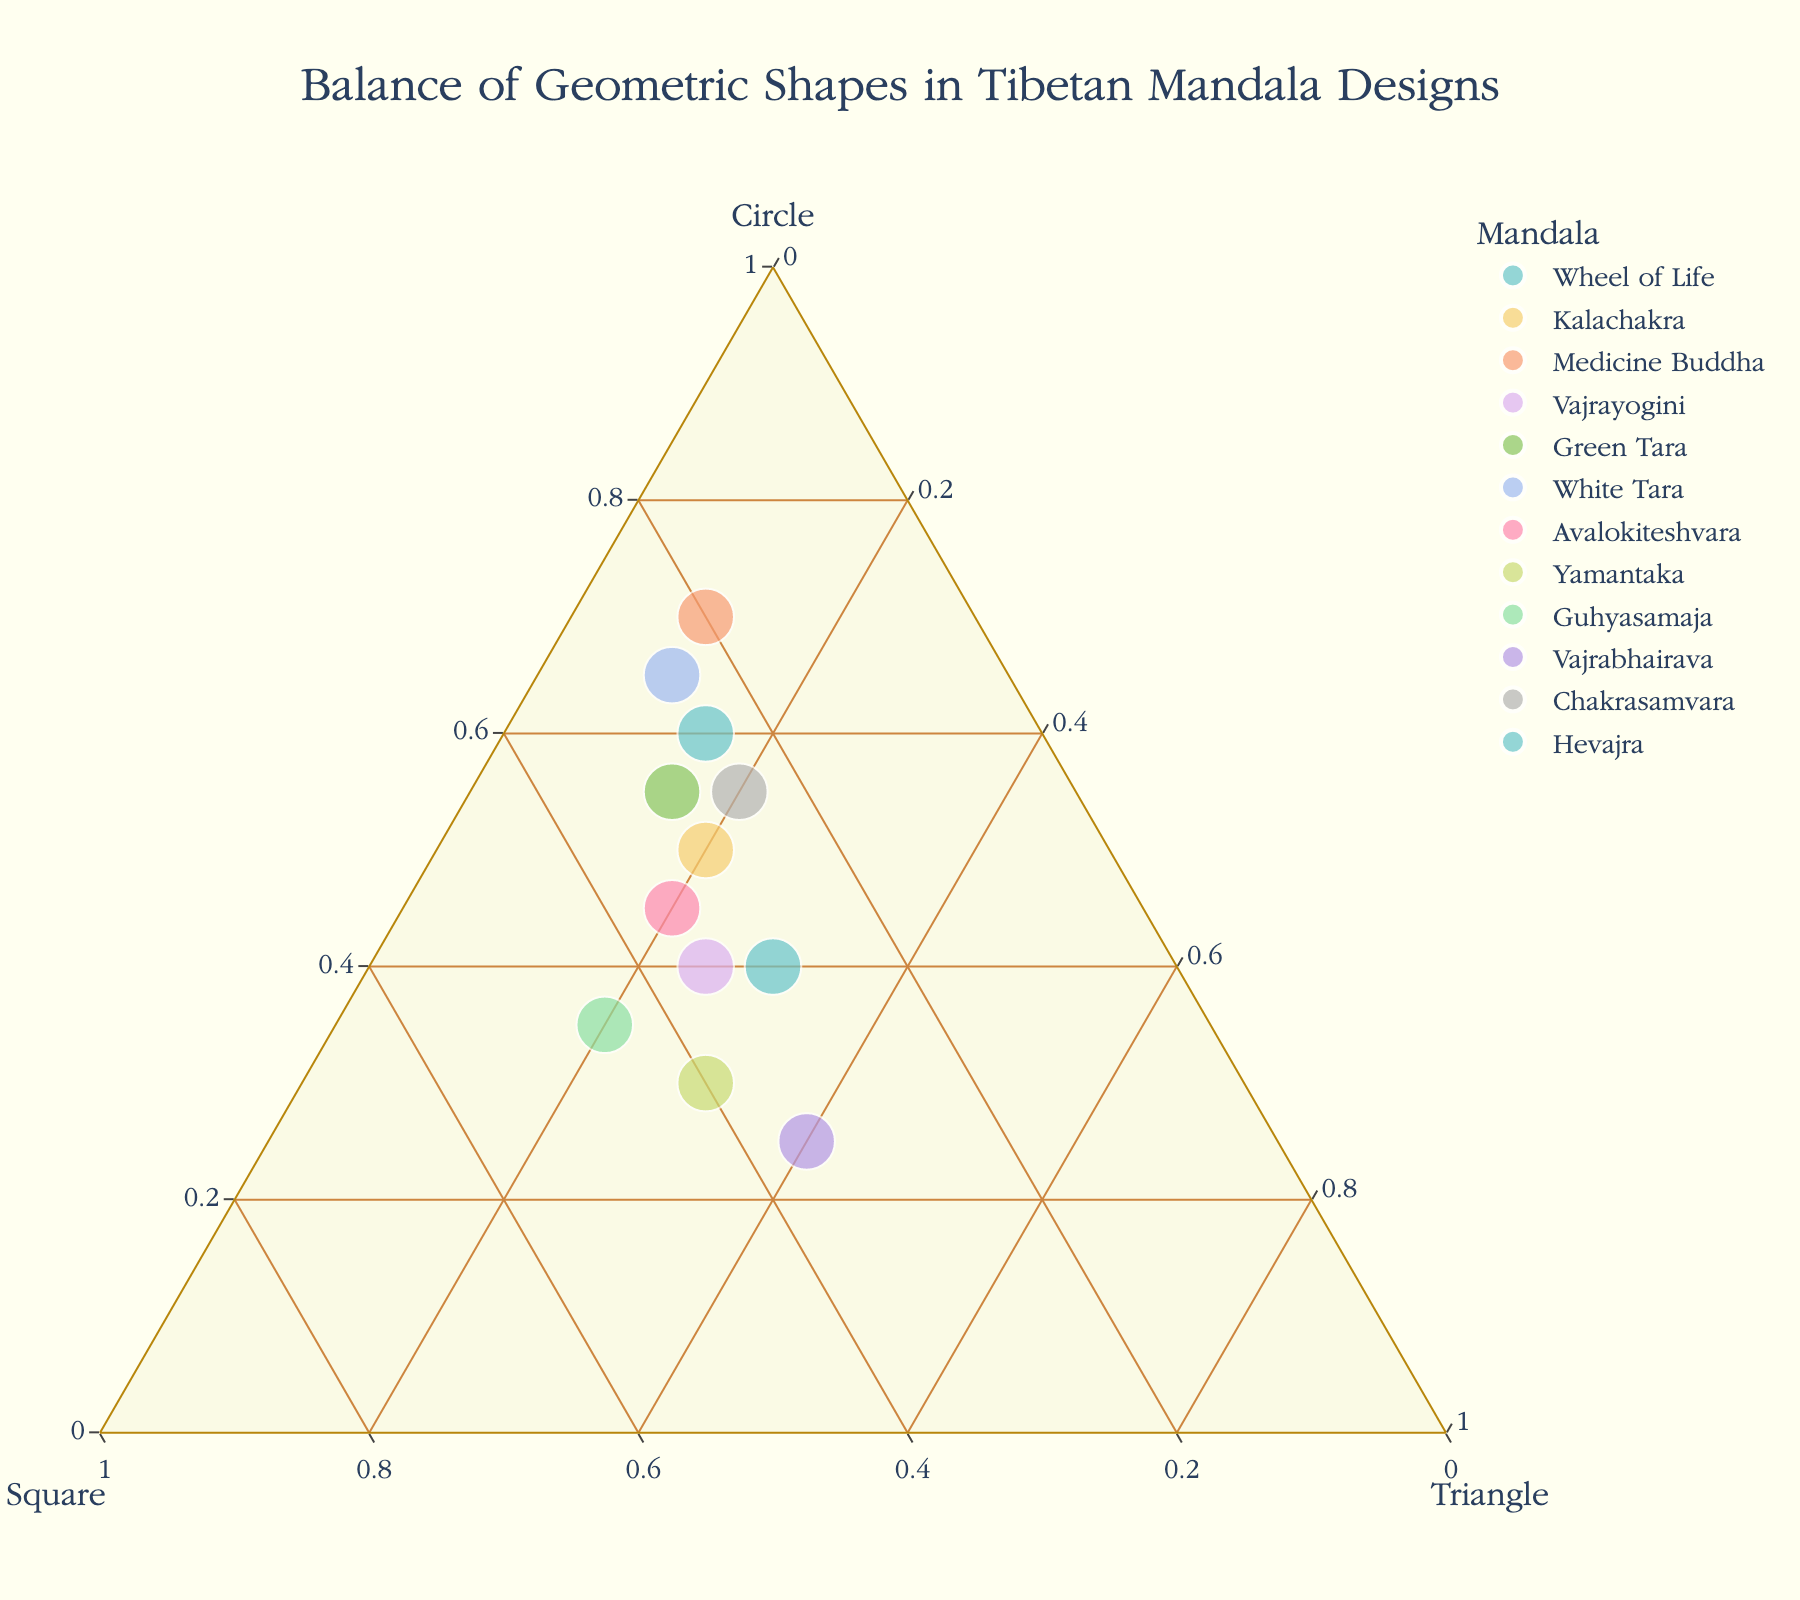what is the title of the plot? The title is displayed at the top of the plot and describes what the plot is about.
Answer: Balance of Geometric Shapes in Tibetan Mandala Designs How many data points are represented in the plot? The plot visualizes each mandala as an individual data point. Counting the number of distinct points will give the total number of data points.
Answer: 12 Which mandala has the highest proportion of triangles? Look for the point closest to the triangle vertex of the ternary plot, representing the highest proportion of triangles.
Answer: Vajrabhairava Which mandala is located exactly in the middle of the plot, and what does it indicate? The middle of the ternary plot would equally balance the three shapes. Identify the point closest to the center of the plot.
Answer: None Which mandala has an equal proportion of circles and squares? Find the point along the axis that equidistantly splits the circle and square percentages.
Answer: Yamantaka Compare and contrast the shapes distribution of "Wheel of Life" and "Kalachakra". Which one has more circles? Locate the points for "Wheel of Life" and "Kalachakra" and compare their distances to the circle vertex. The point closer to the vertex indicates a higher proportion of circles.
Answer: Wheel of Life Which mandala has an equal proportion of squares and triangles? Find the point on the plot where the proportions of squares and triangles are equal by isolating the points along the line between the square and triangle vertexes.
Answer: Hevajra What is the overall trend about the balance of geometric shapes in Tibetan Mandala Designs? Observe the general spread of points in the plot to determine any patterns such as clusters, symmetry, or tendencies towards specific shapes.
Answer: Most mandalas have a higher proportion of circles 